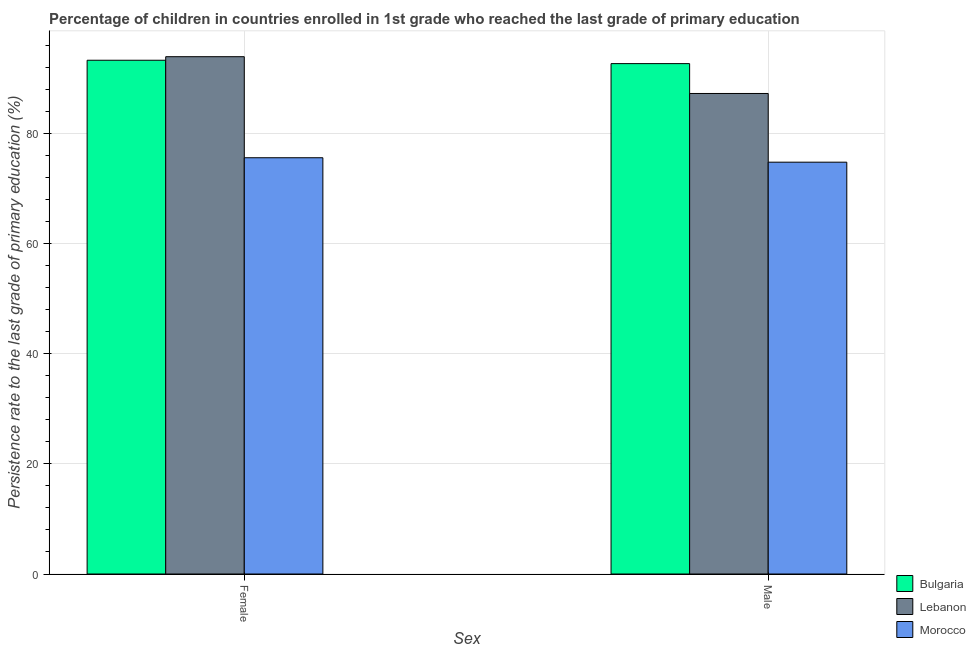How many different coloured bars are there?
Offer a terse response. 3. Are the number of bars per tick equal to the number of legend labels?
Make the answer very short. Yes. Are the number of bars on each tick of the X-axis equal?
Provide a succinct answer. Yes. What is the label of the 2nd group of bars from the left?
Provide a succinct answer. Male. What is the persistence rate of male students in Lebanon?
Offer a terse response. 87.22. Across all countries, what is the maximum persistence rate of male students?
Keep it short and to the point. 92.64. Across all countries, what is the minimum persistence rate of female students?
Keep it short and to the point. 75.56. In which country was the persistence rate of female students maximum?
Your answer should be compact. Lebanon. In which country was the persistence rate of male students minimum?
Ensure brevity in your answer.  Morocco. What is the total persistence rate of male students in the graph?
Offer a terse response. 254.61. What is the difference between the persistence rate of male students in Lebanon and that in Morocco?
Ensure brevity in your answer.  12.47. What is the difference between the persistence rate of male students in Lebanon and the persistence rate of female students in Morocco?
Offer a terse response. 11.67. What is the average persistence rate of male students per country?
Offer a terse response. 84.87. What is the difference between the persistence rate of female students and persistence rate of male students in Morocco?
Your answer should be compact. 0.81. In how many countries, is the persistence rate of female students greater than 16 %?
Your answer should be compact. 3. What is the ratio of the persistence rate of male students in Bulgaria to that in Morocco?
Make the answer very short. 1.24. Is the persistence rate of male students in Bulgaria less than that in Lebanon?
Make the answer very short. No. What does the 3rd bar from the left in Female represents?
Provide a short and direct response. Morocco. What does the 2nd bar from the right in Male represents?
Offer a very short reply. Lebanon. Are all the bars in the graph horizontal?
Offer a very short reply. No. What is the difference between two consecutive major ticks on the Y-axis?
Your response must be concise. 20. Does the graph contain grids?
Give a very brief answer. Yes. How many legend labels are there?
Provide a short and direct response. 3. How are the legend labels stacked?
Your answer should be very brief. Vertical. What is the title of the graph?
Ensure brevity in your answer.  Percentage of children in countries enrolled in 1st grade who reached the last grade of primary education. Does "High income: OECD" appear as one of the legend labels in the graph?
Your answer should be very brief. No. What is the label or title of the X-axis?
Your response must be concise. Sex. What is the label or title of the Y-axis?
Your answer should be very brief. Persistence rate to the last grade of primary education (%). What is the Persistence rate to the last grade of primary education (%) of Bulgaria in Female?
Your answer should be compact. 93.25. What is the Persistence rate to the last grade of primary education (%) in Lebanon in Female?
Give a very brief answer. 93.9. What is the Persistence rate to the last grade of primary education (%) of Morocco in Female?
Your answer should be very brief. 75.56. What is the Persistence rate to the last grade of primary education (%) of Bulgaria in Male?
Your response must be concise. 92.64. What is the Persistence rate to the last grade of primary education (%) of Lebanon in Male?
Keep it short and to the point. 87.22. What is the Persistence rate to the last grade of primary education (%) of Morocco in Male?
Ensure brevity in your answer.  74.75. Across all Sex, what is the maximum Persistence rate to the last grade of primary education (%) of Bulgaria?
Your response must be concise. 93.25. Across all Sex, what is the maximum Persistence rate to the last grade of primary education (%) in Lebanon?
Give a very brief answer. 93.9. Across all Sex, what is the maximum Persistence rate to the last grade of primary education (%) of Morocco?
Offer a terse response. 75.56. Across all Sex, what is the minimum Persistence rate to the last grade of primary education (%) of Bulgaria?
Ensure brevity in your answer.  92.64. Across all Sex, what is the minimum Persistence rate to the last grade of primary education (%) of Lebanon?
Your answer should be compact. 87.22. Across all Sex, what is the minimum Persistence rate to the last grade of primary education (%) in Morocco?
Make the answer very short. 74.75. What is the total Persistence rate to the last grade of primary education (%) of Bulgaria in the graph?
Provide a succinct answer. 185.9. What is the total Persistence rate to the last grade of primary education (%) of Lebanon in the graph?
Offer a very short reply. 181.12. What is the total Persistence rate to the last grade of primary education (%) of Morocco in the graph?
Provide a short and direct response. 150.31. What is the difference between the Persistence rate to the last grade of primary education (%) of Bulgaria in Female and that in Male?
Your response must be concise. 0.61. What is the difference between the Persistence rate to the last grade of primary education (%) of Lebanon in Female and that in Male?
Provide a succinct answer. 6.68. What is the difference between the Persistence rate to the last grade of primary education (%) in Morocco in Female and that in Male?
Your answer should be compact. 0.81. What is the difference between the Persistence rate to the last grade of primary education (%) in Bulgaria in Female and the Persistence rate to the last grade of primary education (%) in Lebanon in Male?
Offer a terse response. 6.03. What is the difference between the Persistence rate to the last grade of primary education (%) of Bulgaria in Female and the Persistence rate to the last grade of primary education (%) of Morocco in Male?
Your answer should be very brief. 18.5. What is the difference between the Persistence rate to the last grade of primary education (%) in Lebanon in Female and the Persistence rate to the last grade of primary education (%) in Morocco in Male?
Offer a very short reply. 19.15. What is the average Persistence rate to the last grade of primary education (%) of Bulgaria per Sex?
Give a very brief answer. 92.95. What is the average Persistence rate to the last grade of primary education (%) in Lebanon per Sex?
Your answer should be very brief. 90.56. What is the average Persistence rate to the last grade of primary education (%) in Morocco per Sex?
Your answer should be very brief. 75.15. What is the difference between the Persistence rate to the last grade of primary education (%) in Bulgaria and Persistence rate to the last grade of primary education (%) in Lebanon in Female?
Your answer should be very brief. -0.65. What is the difference between the Persistence rate to the last grade of primary education (%) of Bulgaria and Persistence rate to the last grade of primary education (%) of Morocco in Female?
Your answer should be compact. 17.7. What is the difference between the Persistence rate to the last grade of primary education (%) in Lebanon and Persistence rate to the last grade of primary education (%) in Morocco in Female?
Give a very brief answer. 18.34. What is the difference between the Persistence rate to the last grade of primary education (%) of Bulgaria and Persistence rate to the last grade of primary education (%) of Lebanon in Male?
Offer a very short reply. 5.42. What is the difference between the Persistence rate to the last grade of primary education (%) in Bulgaria and Persistence rate to the last grade of primary education (%) in Morocco in Male?
Make the answer very short. 17.89. What is the difference between the Persistence rate to the last grade of primary education (%) of Lebanon and Persistence rate to the last grade of primary education (%) of Morocco in Male?
Provide a short and direct response. 12.47. What is the ratio of the Persistence rate to the last grade of primary education (%) in Bulgaria in Female to that in Male?
Make the answer very short. 1.01. What is the ratio of the Persistence rate to the last grade of primary education (%) of Lebanon in Female to that in Male?
Your answer should be compact. 1.08. What is the ratio of the Persistence rate to the last grade of primary education (%) of Morocco in Female to that in Male?
Your response must be concise. 1.01. What is the difference between the highest and the second highest Persistence rate to the last grade of primary education (%) of Bulgaria?
Ensure brevity in your answer.  0.61. What is the difference between the highest and the second highest Persistence rate to the last grade of primary education (%) of Lebanon?
Keep it short and to the point. 6.68. What is the difference between the highest and the second highest Persistence rate to the last grade of primary education (%) of Morocco?
Provide a succinct answer. 0.81. What is the difference between the highest and the lowest Persistence rate to the last grade of primary education (%) in Bulgaria?
Ensure brevity in your answer.  0.61. What is the difference between the highest and the lowest Persistence rate to the last grade of primary education (%) of Lebanon?
Give a very brief answer. 6.68. What is the difference between the highest and the lowest Persistence rate to the last grade of primary education (%) of Morocco?
Your response must be concise. 0.81. 